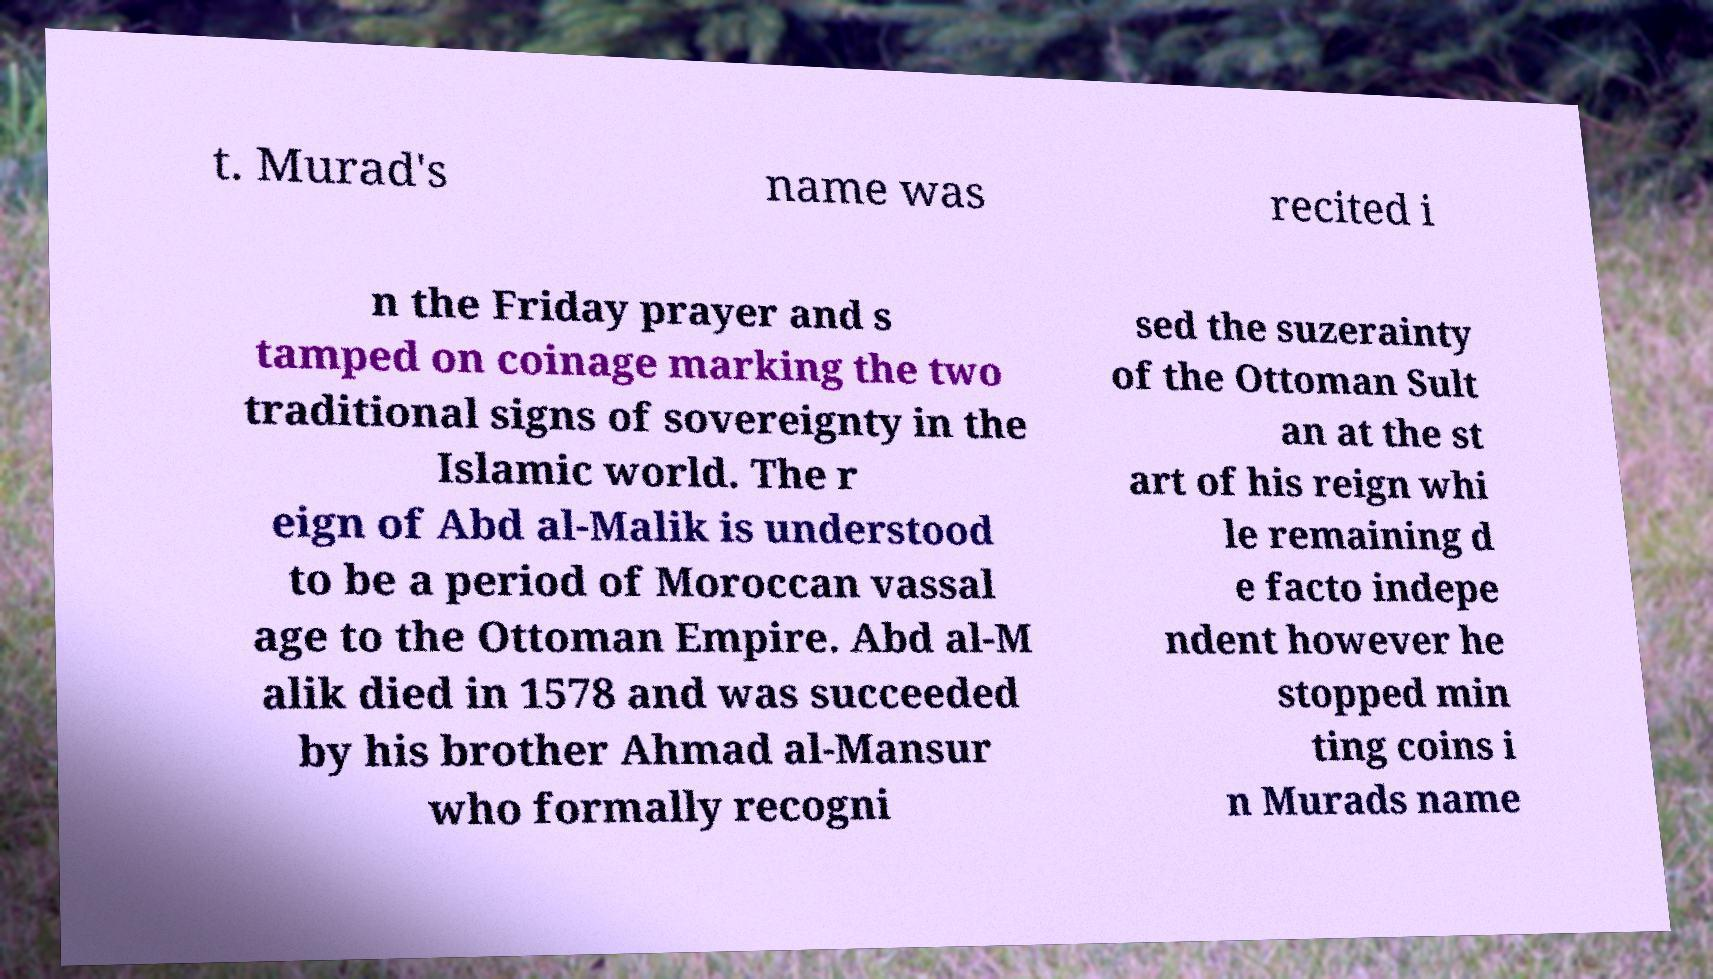Can you accurately transcribe the text from the provided image for me? t. Murad's name was recited i n the Friday prayer and s tamped on coinage marking the two traditional signs of sovereignty in the Islamic world. The r eign of Abd al-Malik is understood to be a period of Moroccan vassal age to the Ottoman Empire. Abd al-M alik died in 1578 and was succeeded by his brother Ahmad al-Mansur who formally recogni sed the suzerainty of the Ottoman Sult an at the st art of his reign whi le remaining d e facto indepe ndent however he stopped min ting coins i n Murads name 